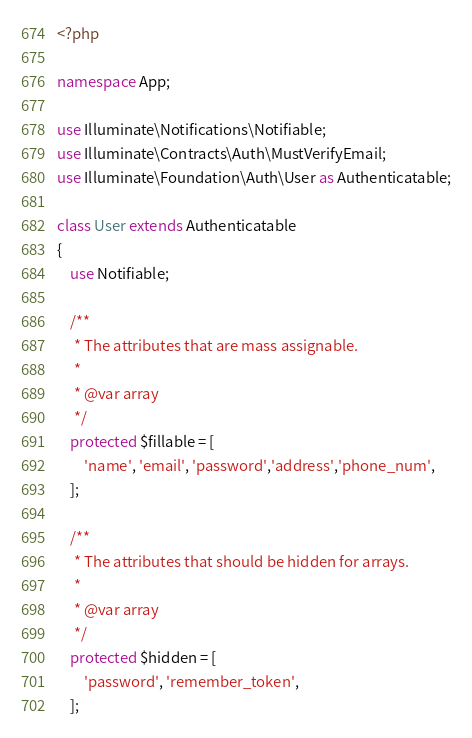<code> <loc_0><loc_0><loc_500><loc_500><_PHP_><?php

namespace App;

use Illuminate\Notifications\Notifiable;
use Illuminate\Contracts\Auth\MustVerifyEmail;
use Illuminate\Foundation\Auth\User as Authenticatable;

class User extends Authenticatable
{
    use Notifiable;

    /**
     * The attributes that are mass assignable.
     *
     * @var array
     */
    protected $fillable = [
        'name', 'email', 'password','address','phone_num',
    ];

    /**
     * The attributes that should be hidden for arrays.
     *
     * @var array
     */
    protected $hidden = [
        'password', 'remember_token',
    ];
</code> 